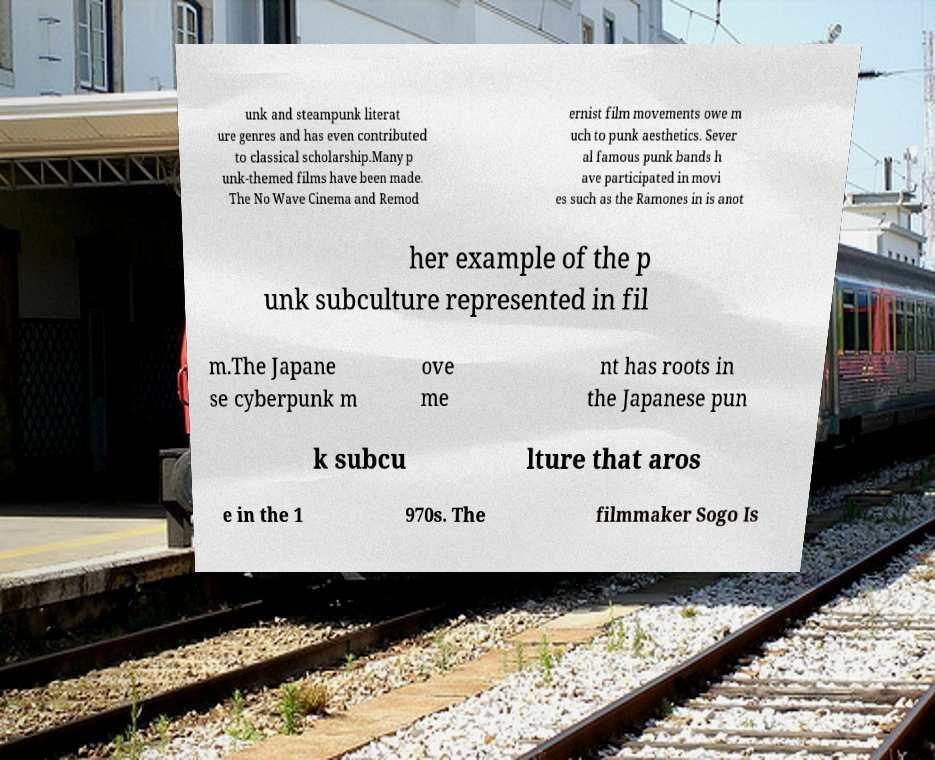For documentation purposes, I need the text within this image transcribed. Could you provide that? unk and steampunk literat ure genres and has even contributed to classical scholarship.Many p unk-themed films have been made. The No Wave Cinema and Remod ernist film movements owe m uch to punk aesthetics. Sever al famous punk bands h ave participated in movi es such as the Ramones in is anot her example of the p unk subculture represented in fil m.The Japane se cyberpunk m ove me nt has roots in the Japanese pun k subcu lture that aros e in the 1 970s. The filmmaker Sogo Is 